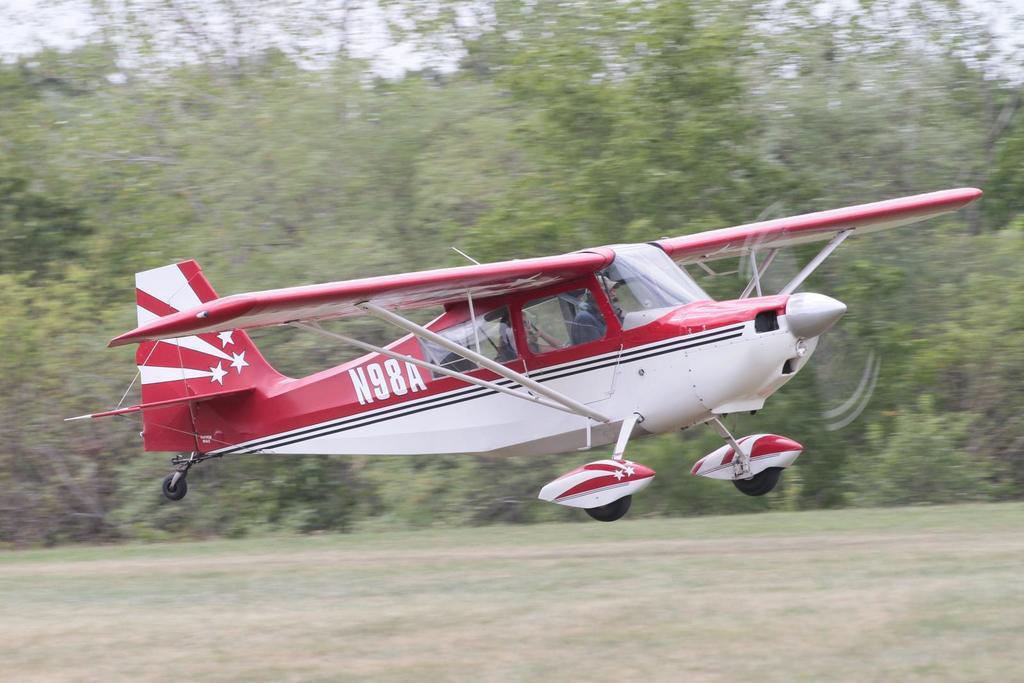Please provide a concise description of this image. In the image i can see the aeroplane. A text written on it and i can also see the trees in the background. 